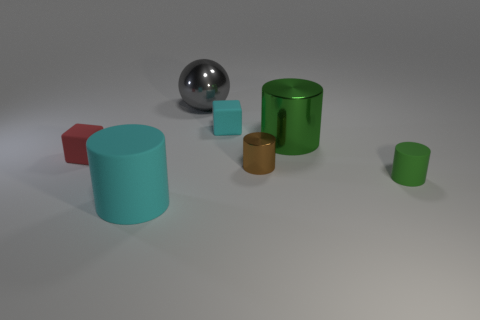Are there more small cubes than large purple rubber blocks?
Your response must be concise. Yes. What size is the rubber object that is both to the left of the small green matte cylinder and in front of the tiny red block?
Provide a succinct answer. Large. Is the large thing on the right side of the sphere made of the same material as the tiny thing in front of the brown shiny thing?
Your answer should be compact. No. There is a red thing that is the same size as the cyan block; what is its shape?
Ensure brevity in your answer.  Cube. Are there fewer small purple blocks than tiny brown objects?
Offer a terse response. Yes. There is a small matte block to the left of the large cyan cylinder; is there a small red matte object that is in front of it?
Your response must be concise. No. There is a shiny cylinder that is behind the small rubber thing that is to the left of the large cyan cylinder; are there any small brown shiny objects that are on the right side of it?
Offer a very short reply. No. There is a big metallic object that is to the right of the cyan block; is its shape the same as the cyan object to the right of the large gray thing?
Your answer should be compact. No. There is a tiny cylinder that is made of the same material as the gray ball; what is its color?
Your answer should be compact. Brown. Are there fewer large matte cylinders that are on the left side of the red cube than tiny green metallic things?
Give a very brief answer. No. 